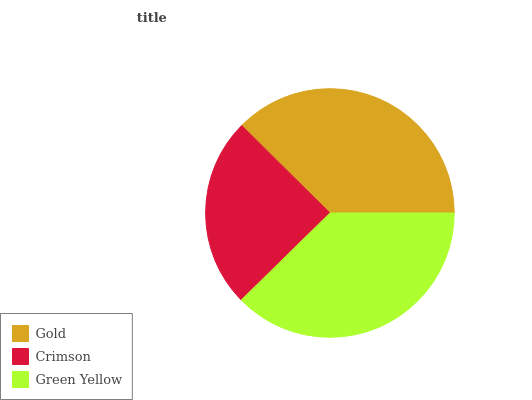Is Crimson the minimum?
Answer yes or no. Yes. Is Green Yellow the maximum?
Answer yes or no. Yes. Is Green Yellow the minimum?
Answer yes or no. No. Is Crimson the maximum?
Answer yes or no. No. Is Green Yellow greater than Crimson?
Answer yes or no. Yes. Is Crimson less than Green Yellow?
Answer yes or no. Yes. Is Crimson greater than Green Yellow?
Answer yes or no. No. Is Green Yellow less than Crimson?
Answer yes or no. No. Is Gold the high median?
Answer yes or no. Yes. Is Gold the low median?
Answer yes or no. Yes. Is Crimson the high median?
Answer yes or no. No. Is Green Yellow the low median?
Answer yes or no. No. 